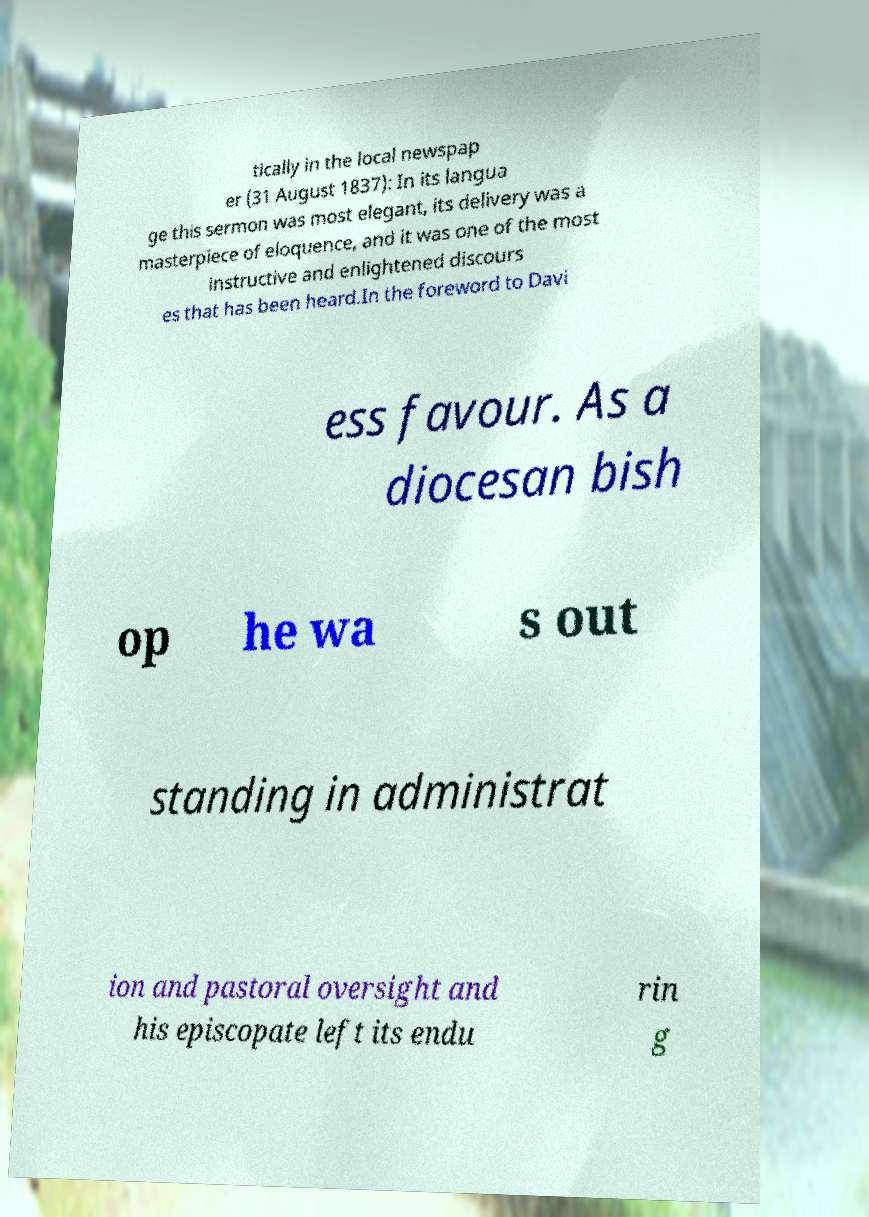What messages or text are displayed in this image? I need them in a readable, typed format. tically in the local newspap er (31 August 1837): In its langua ge this sermon was most elegant‚ its delivery was a masterpiece of eloquence, and it was one of the most instructive and enlightened discours es that has been heard.In the foreword to Davi ess favour. As a diocesan bish op he wa s out standing in administrat ion and pastoral oversight and his episcopate left its endu rin g 